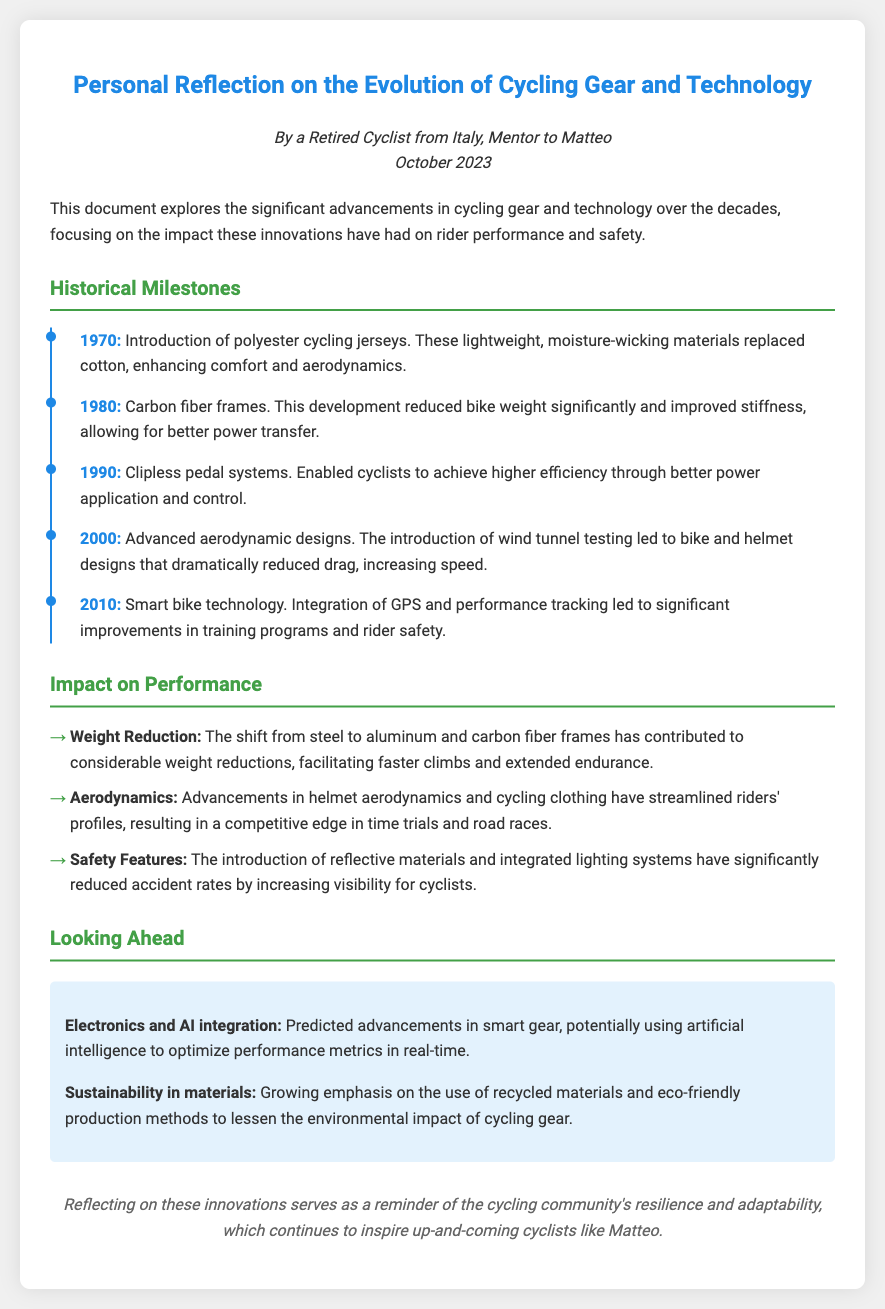What year did polyester cycling jerseys get introduced? The document states that polyester cycling jerseys were introduced in 1970.
Answer: 1970 What significant material replaced cotton in cycling jerseys? The document mentions that polyester replaced cotton for cycling jerseys.
Answer: Polyester What major advancement in cycling technology occurred in 1980? This refers to the introduction of carbon fiber frames as a significant advancement in cycling technology.
Answer: Carbon fiber frames Which pedal system was introduced in the 1990s? The document refers to clipless pedal systems as the advancement introduced in that decade.
Answer: Clipless pedal systems What year marks the introduction of smart bike technology? The document specifies that smart bike technology was introduced in 2010.
Answer: 2010 How have bike and helmet designs changed in 2000? In 2000, aerodynamic designs were introduced, leading to reduced drag and increased speed.
Answer: Aerodynamic designs What is one predicted future trend in cycling gear? The document mentions that electronics and AI integration are predicted advancements in smart gear.
Answer: Electronics and AI integration What has contributed to improved cyclist visibility for safety? The introduction of reflective materials and integrated lighting systems contributes to better visibility.
Answer: Reflective materials and integrated lighting systems What significant impact has weight reduction had on cycling? Weight reduction has led to faster climbs and extended endurance for cyclists.
Answer: Faster climbs and extended endurance What does the conclusion reflect on regarding innovations? The conclusion reflects on the resilience and adaptability of the cycling community.
Answer: Resilience and adaptability 